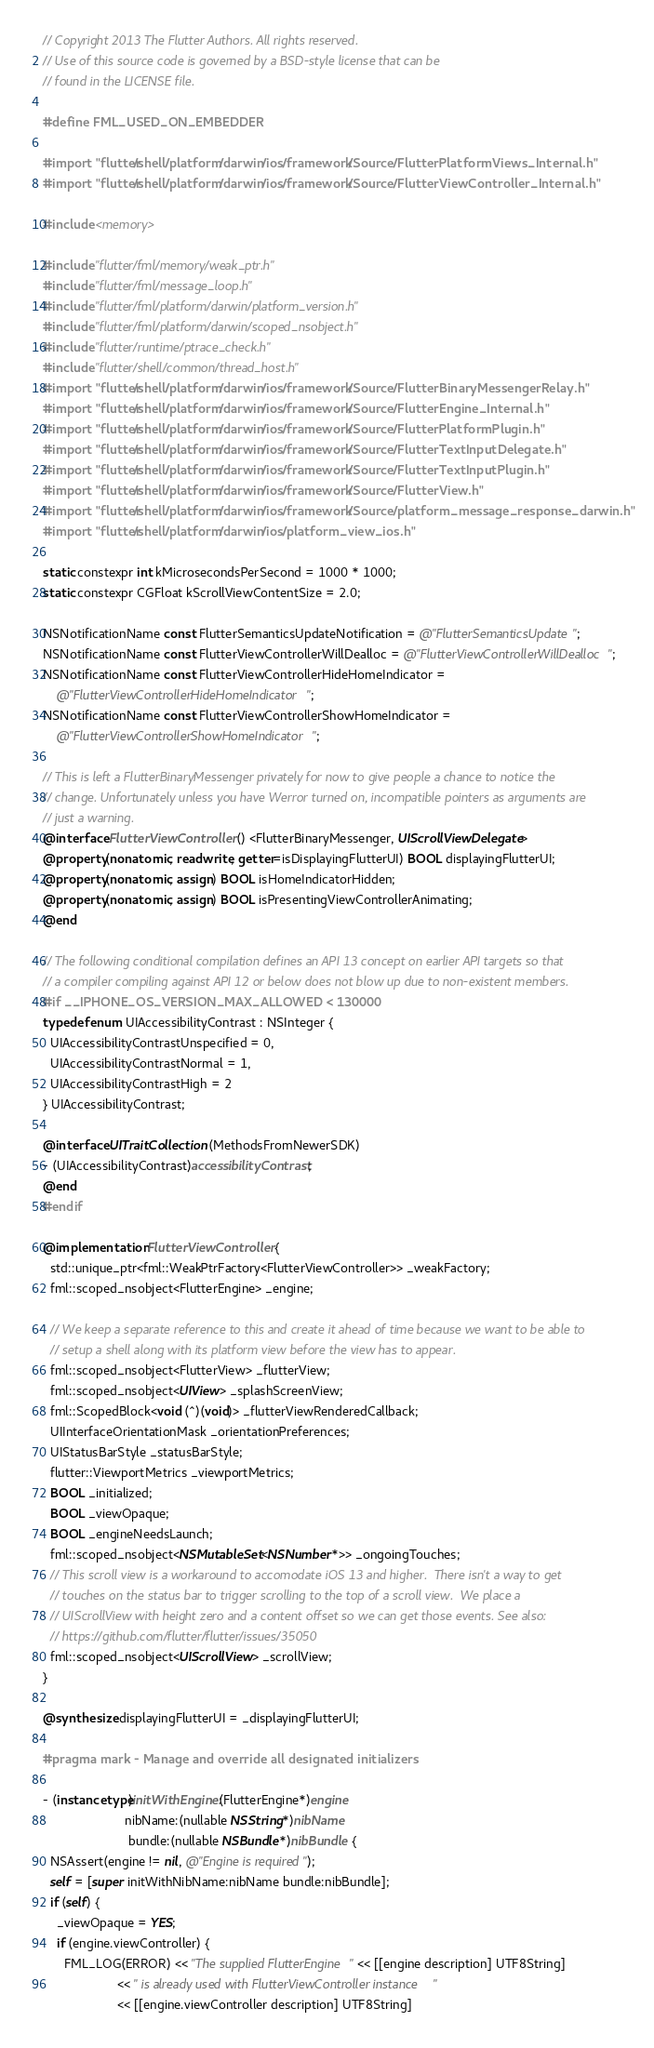<code> <loc_0><loc_0><loc_500><loc_500><_ObjectiveC_>// Copyright 2013 The Flutter Authors. All rights reserved.
// Use of this source code is governed by a BSD-style license that can be
// found in the LICENSE file.

#define FML_USED_ON_EMBEDDER

#import "flutter/shell/platform/darwin/ios/framework/Source/FlutterPlatformViews_Internal.h"
#import "flutter/shell/platform/darwin/ios/framework/Source/FlutterViewController_Internal.h"

#include <memory>

#include "flutter/fml/memory/weak_ptr.h"
#include "flutter/fml/message_loop.h"
#include "flutter/fml/platform/darwin/platform_version.h"
#include "flutter/fml/platform/darwin/scoped_nsobject.h"
#include "flutter/runtime/ptrace_check.h"
#include "flutter/shell/common/thread_host.h"
#import "flutter/shell/platform/darwin/ios/framework/Source/FlutterBinaryMessengerRelay.h"
#import "flutter/shell/platform/darwin/ios/framework/Source/FlutterEngine_Internal.h"
#import "flutter/shell/platform/darwin/ios/framework/Source/FlutterPlatformPlugin.h"
#import "flutter/shell/platform/darwin/ios/framework/Source/FlutterTextInputDelegate.h"
#import "flutter/shell/platform/darwin/ios/framework/Source/FlutterTextInputPlugin.h"
#import "flutter/shell/platform/darwin/ios/framework/Source/FlutterView.h"
#import "flutter/shell/platform/darwin/ios/framework/Source/platform_message_response_darwin.h"
#import "flutter/shell/platform/darwin/ios/platform_view_ios.h"

static constexpr int kMicrosecondsPerSecond = 1000 * 1000;
static constexpr CGFloat kScrollViewContentSize = 2.0;

NSNotificationName const FlutterSemanticsUpdateNotification = @"FlutterSemanticsUpdate";
NSNotificationName const FlutterViewControllerWillDealloc = @"FlutterViewControllerWillDealloc";
NSNotificationName const FlutterViewControllerHideHomeIndicator =
    @"FlutterViewControllerHideHomeIndicator";
NSNotificationName const FlutterViewControllerShowHomeIndicator =
    @"FlutterViewControllerShowHomeIndicator";

// This is left a FlutterBinaryMessenger privately for now to give people a chance to notice the
// change. Unfortunately unless you have Werror turned on, incompatible pointers as arguments are
// just a warning.
@interface FlutterViewController () <FlutterBinaryMessenger, UIScrollViewDelegate>
@property(nonatomic, readwrite, getter=isDisplayingFlutterUI) BOOL displayingFlutterUI;
@property(nonatomic, assign) BOOL isHomeIndicatorHidden;
@property(nonatomic, assign) BOOL isPresentingViewControllerAnimating;
@end

// The following conditional compilation defines an API 13 concept on earlier API targets so that
// a compiler compiling against API 12 or below does not blow up due to non-existent members.
#if __IPHONE_OS_VERSION_MAX_ALLOWED < 130000
typedef enum UIAccessibilityContrast : NSInteger {
  UIAccessibilityContrastUnspecified = 0,
  UIAccessibilityContrastNormal = 1,
  UIAccessibilityContrastHigh = 2
} UIAccessibilityContrast;

@interface UITraitCollection (MethodsFromNewerSDK)
- (UIAccessibilityContrast)accessibilityContrast;
@end
#endif

@implementation FlutterViewController {
  std::unique_ptr<fml::WeakPtrFactory<FlutterViewController>> _weakFactory;
  fml::scoped_nsobject<FlutterEngine> _engine;

  // We keep a separate reference to this and create it ahead of time because we want to be able to
  // setup a shell along with its platform view before the view has to appear.
  fml::scoped_nsobject<FlutterView> _flutterView;
  fml::scoped_nsobject<UIView> _splashScreenView;
  fml::ScopedBlock<void (^)(void)> _flutterViewRenderedCallback;
  UIInterfaceOrientationMask _orientationPreferences;
  UIStatusBarStyle _statusBarStyle;
  flutter::ViewportMetrics _viewportMetrics;
  BOOL _initialized;
  BOOL _viewOpaque;
  BOOL _engineNeedsLaunch;
  fml::scoped_nsobject<NSMutableSet<NSNumber*>> _ongoingTouches;
  // This scroll view is a workaround to accomodate iOS 13 and higher.  There isn't a way to get
  // touches on the status bar to trigger scrolling to the top of a scroll view.  We place a
  // UIScrollView with height zero and a content offset so we can get those events. See also:
  // https://github.com/flutter/flutter/issues/35050
  fml::scoped_nsobject<UIScrollView> _scrollView;
}

@synthesize displayingFlutterUI = _displayingFlutterUI;

#pragma mark - Manage and override all designated initializers

- (instancetype)initWithEngine:(FlutterEngine*)engine
                       nibName:(nullable NSString*)nibName
                        bundle:(nullable NSBundle*)nibBundle {
  NSAssert(engine != nil, @"Engine is required");
  self = [super initWithNibName:nibName bundle:nibBundle];
  if (self) {
    _viewOpaque = YES;
    if (engine.viewController) {
      FML_LOG(ERROR) << "The supplied FlutterEngine " << [[engine description] UTF8String]
                     << " is already used with FlutterViewController instance "
                     << [[engine.viewController description] UTF8String]</code> 